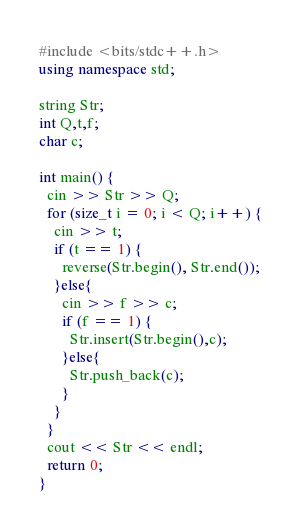Convert code to text. <code><loc_0><loc_0><loc_500><loc_500><_C++_>#include <bits/stdc++.h>
using namespace std;

string Str;
int Q,t,f;
char c;

int main() {
  cin >> Str >> Q;
  for (size_t i = 0; i < Q; i++) {
    cin >> t;
    if (t == 1) {
      reverse(Str.begin(), Str.end());
    }else{
      cin >> f >> c;
      if (f == 1) {
        Str.insert(Str.begin(),c);
      }else{
        Str.push_back(c);
      }
    }
  }
  cout << Str << endl;
  return 0;
}
</code> 